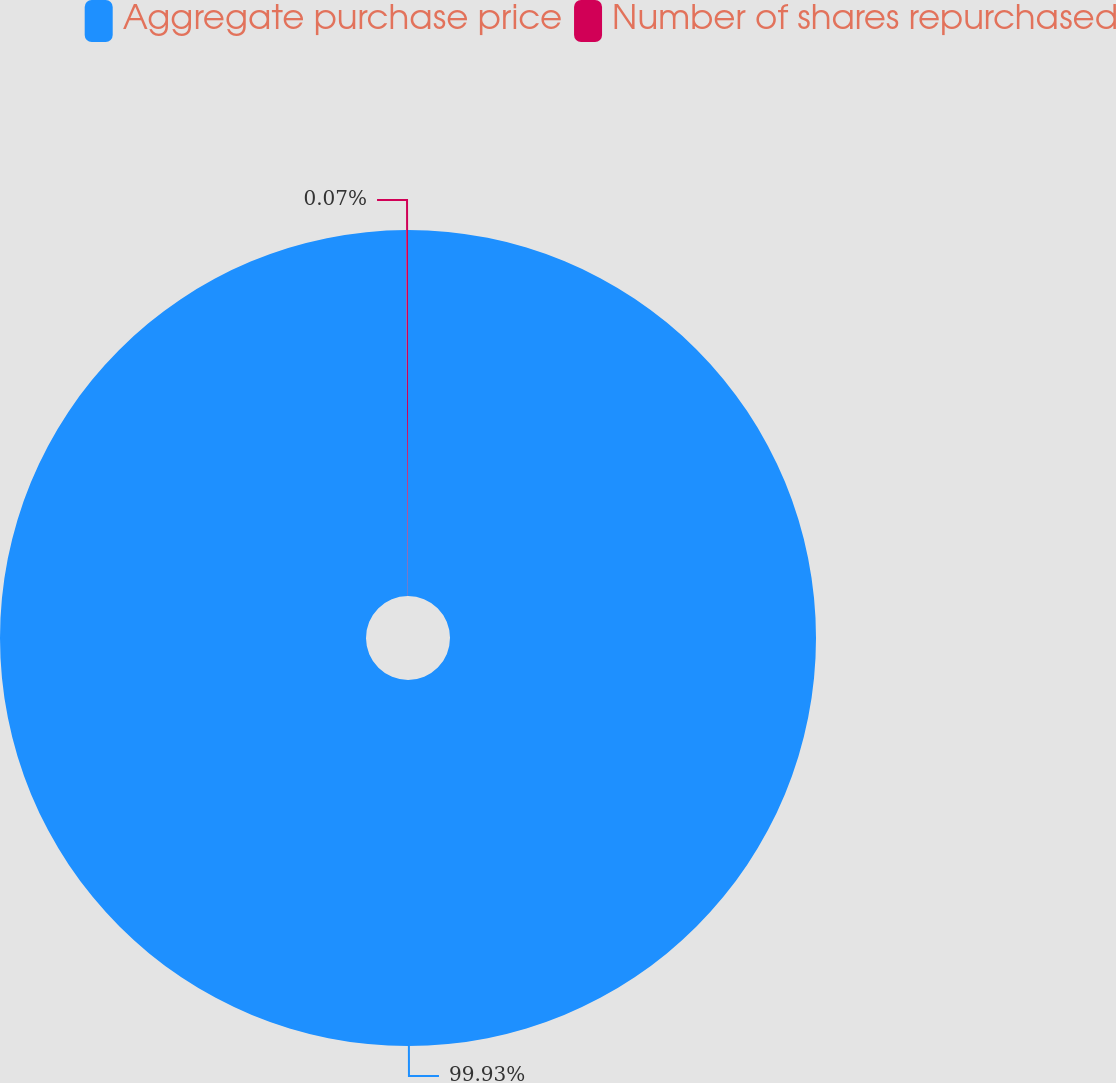Convert chart. <chart><loc_0><loc_0><loc_500><loc_500><pie_chart><fcel>Aggregate purchase price<fcel>Number of shares repurchased<nl><fcel>99.93%<fcel>0.07%<nl></chart> 